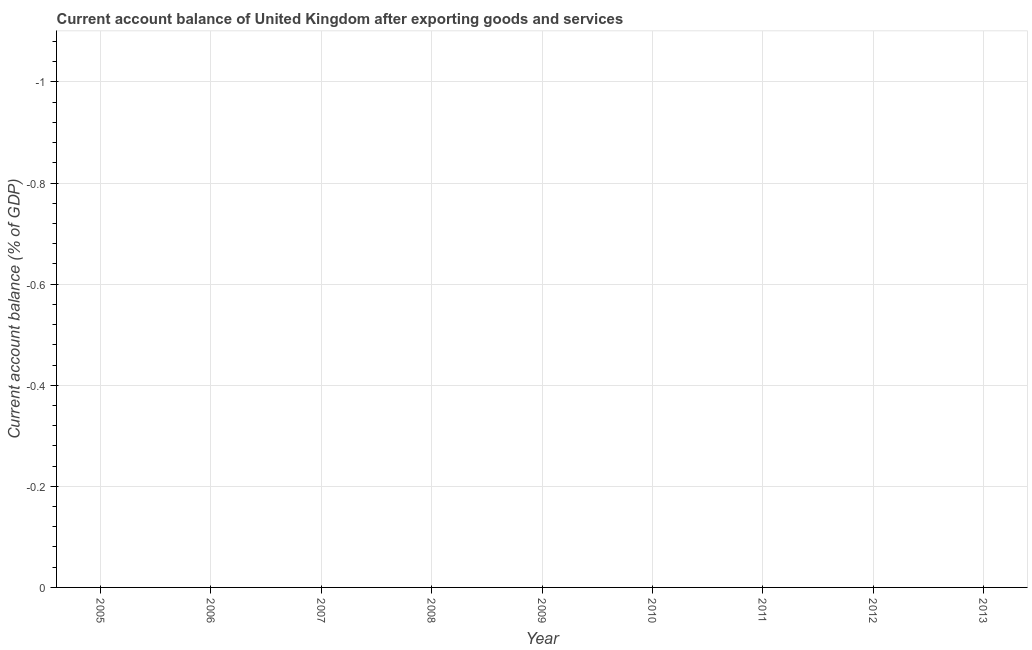Across all years, what is the minimum current account balance?
Provide a succinct answer. 0. What is the average current account balance per year?
Give a very brief answer. 0. In how many years, is the current account balance greater than -0.4800000000000001 %?
Make the answer very short. 0. Does the current account balance monotonically increase over the years?
Give a very brief answer. No. How many lines are there?
Offer a terse response. 0. How many years are there in the graph?
Make the answer very short. 9. What is the difference between two consecutive major ticks on the Y-axis?
Your answer should be compact. 0.2. Are the values on the major ticks of Y-axis written in scientific E-notation?
Provide a short and direct response. No. Does the graph contain any zero values?
Provide a short and direct response. Yes. What is the title of the graph?
Provide a succinct answer. Current account balance of United Kingdom after exporting goods and services. What is the label or title of the Y-axis?
Provide a short and direct response. Current account balance (% of GDP). What is the Current account balance (% of GDP) of 2005?
Offer a very short reply. 0. What is the Current account balance (% of GDP) in 2007?
Provide a short and direct response. 0. What is the Current account balance (% of GDP) in 2008?
Provide a short and direct response. 0. What is the Current account balance (% of GDP) of 2010?
Ensure brevity in your answer.  0. What is the Current account balance (% of GDP) of 2013?
Ensure brevity in your answer.  0. 